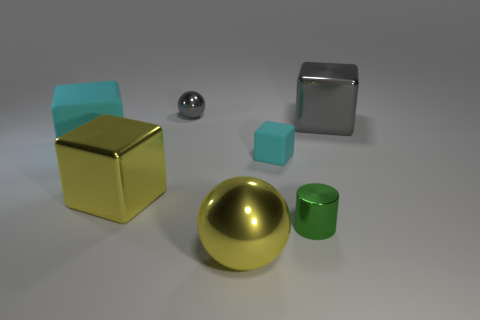Add 1 big purple cylinders. How many objects exist? 8 Subtract all cylinders. How many objects are left? 6 Subtract all large shiny things. Subtract all metal spheres. How many objects are left? 2 Add 4 tiny blocks. How many tiny blocks are left? 5 Add 7 yellow things. How many yellow things exist? 9 Subtract 0 purple balls. How many objects are left? 7 